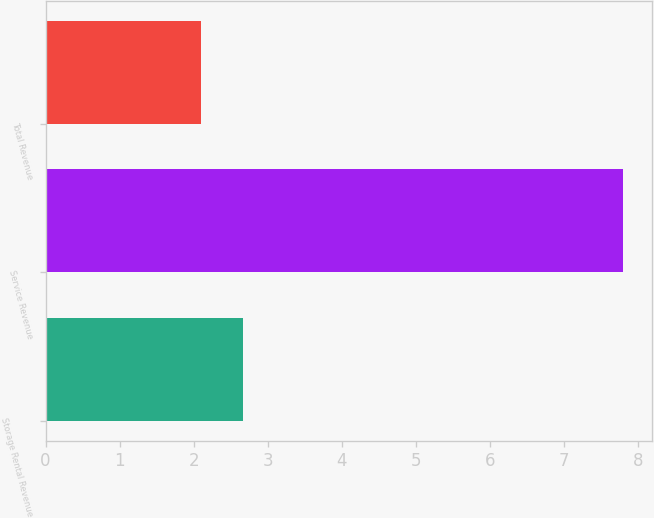Convert chart. <chart><loc_0><loc_0><loc_500><loc_500><bar_chart><fcel>Storage Rental Revenue<fcel>Service Revenue<fcel>Total Revenue<nl><fcel>2.67<fcel>7.8<fcel>2.1<nl></chart> 